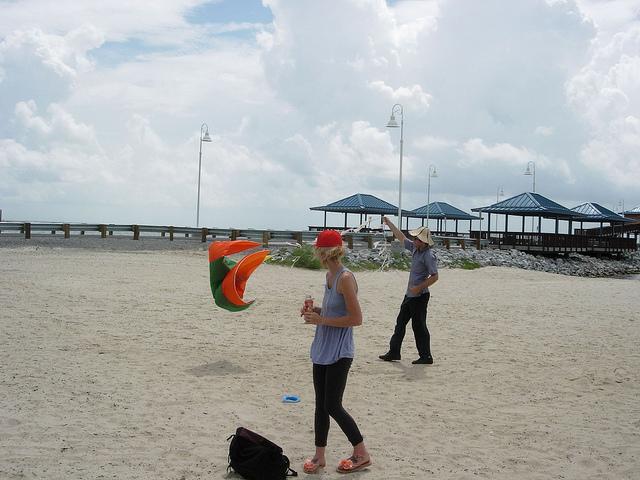Does it look windy enough for this man to fly his kite successfully?
Quick response, please. Yes. What are they doing?
Keep it brief. Flying kite. Why are the man's arms stretched forward?
Be succinct. Holding kite string. What type of hat is the man wearing?
Give a very brief answer. Sun hat. Is this attracted to other men?
Answer briefly. No. 